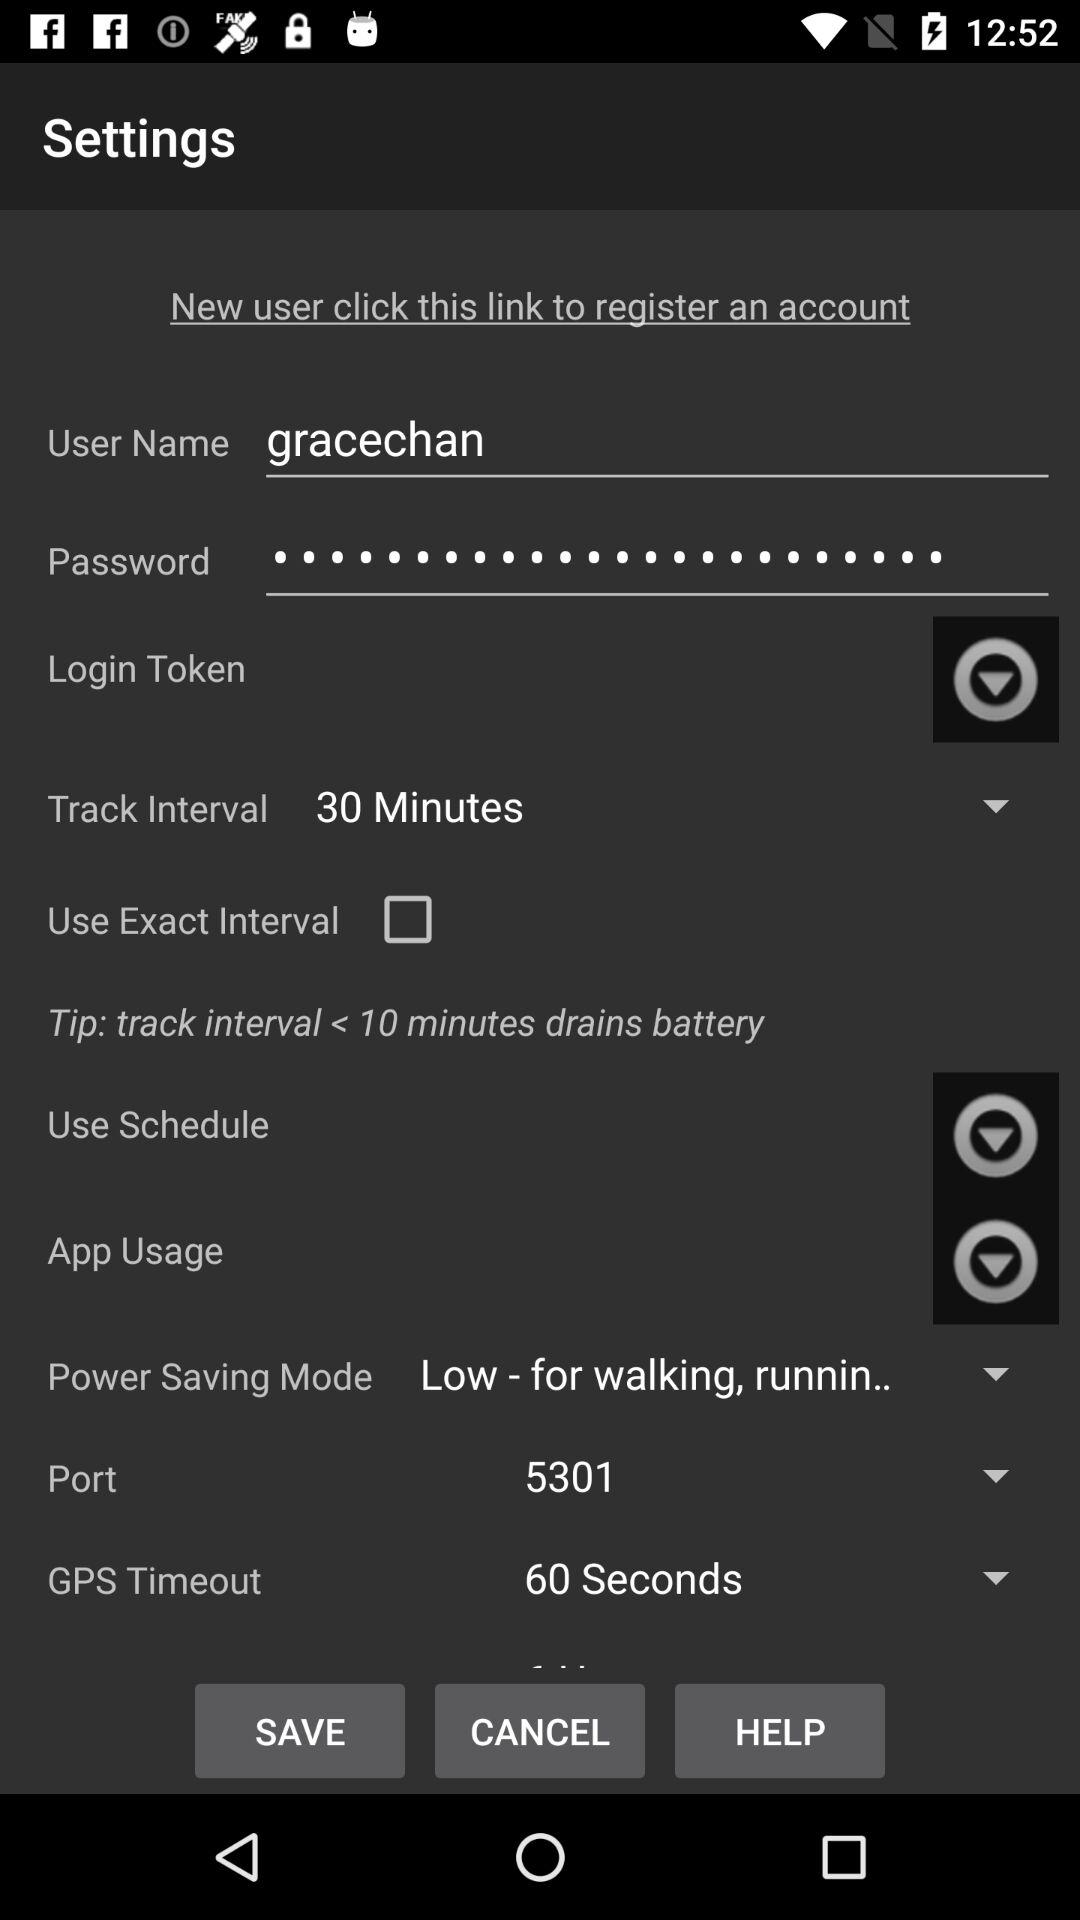Which "GPS Timeout" is selected? The selected "GPS Timeout" is "60 Seconds". 